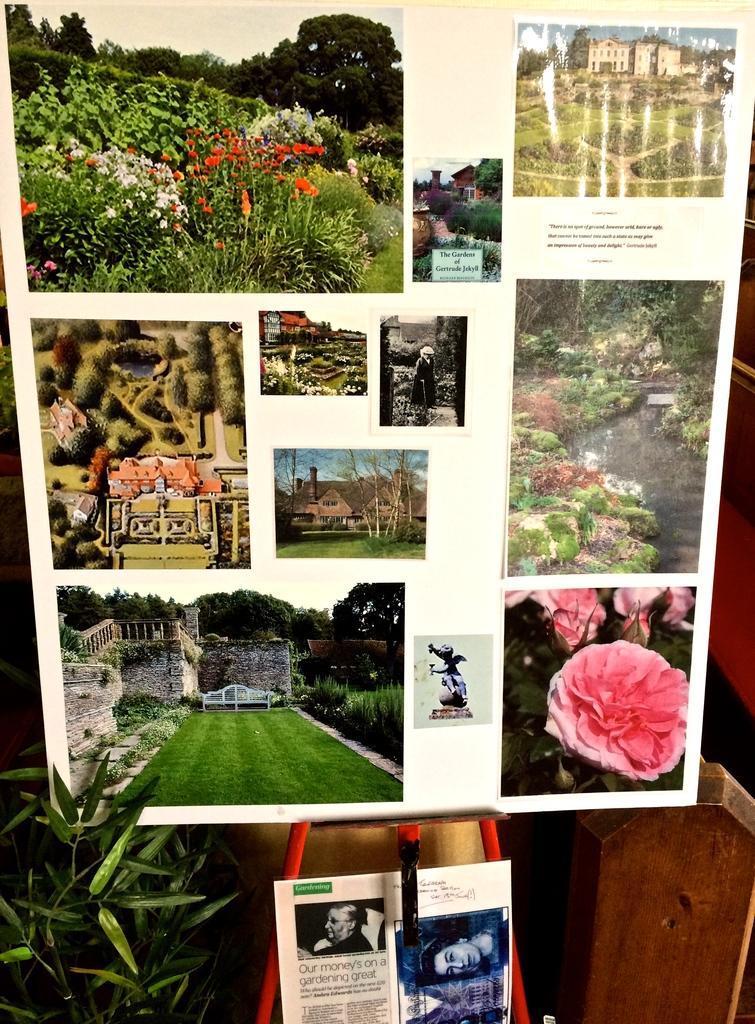Please provide a concise description of this image. In this image we can see pictures are posted to the white color board. At the bottom of the image one plant and picture is there. Right bottom of the image wooden thing is present. 